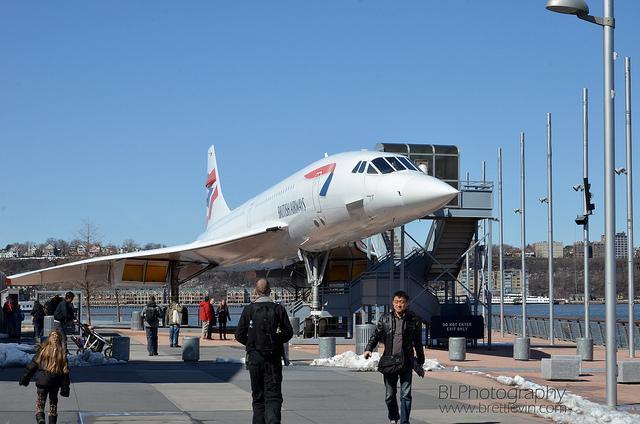How many people are visible?
Give a very brief answer. 3. How many bowls have eggs?
Give a very brief answer. 0. 